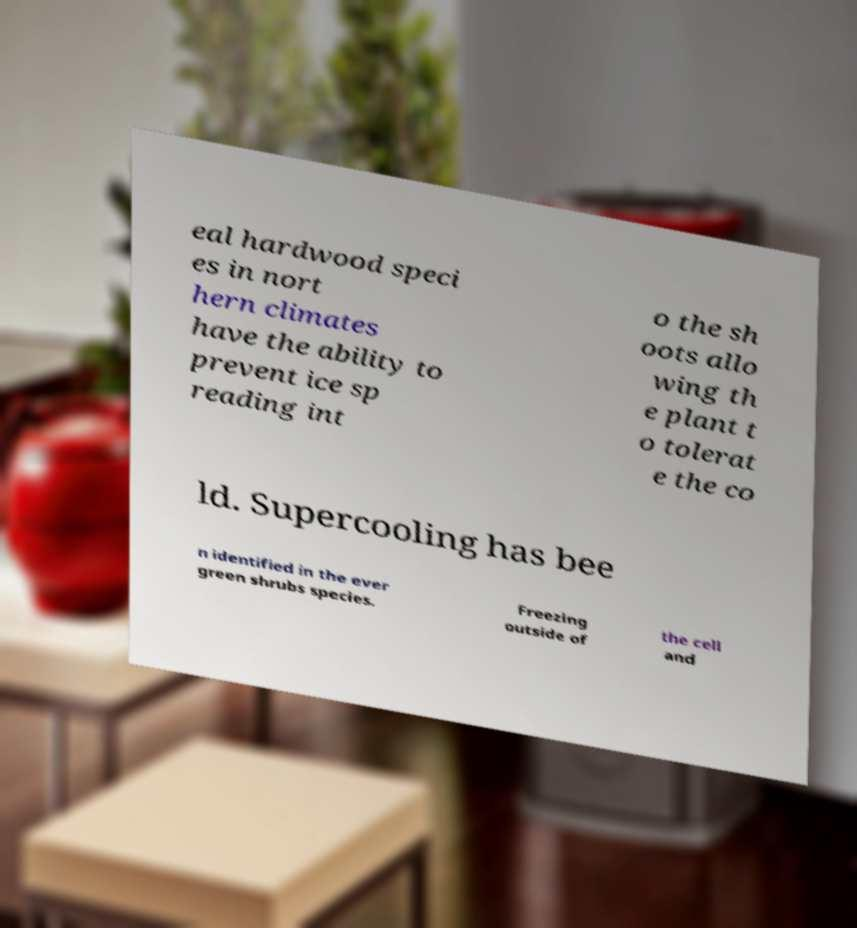Could you extract and type out the text from this image? eal hardwood speci es in nort hern climates have the ability to prevent ice sp reading int o the sh oots allo wing th e plant t o tolerat e the co ld. Supercooling has bee n identified in the ever green shrubs species. Freezing outside of the cell and 